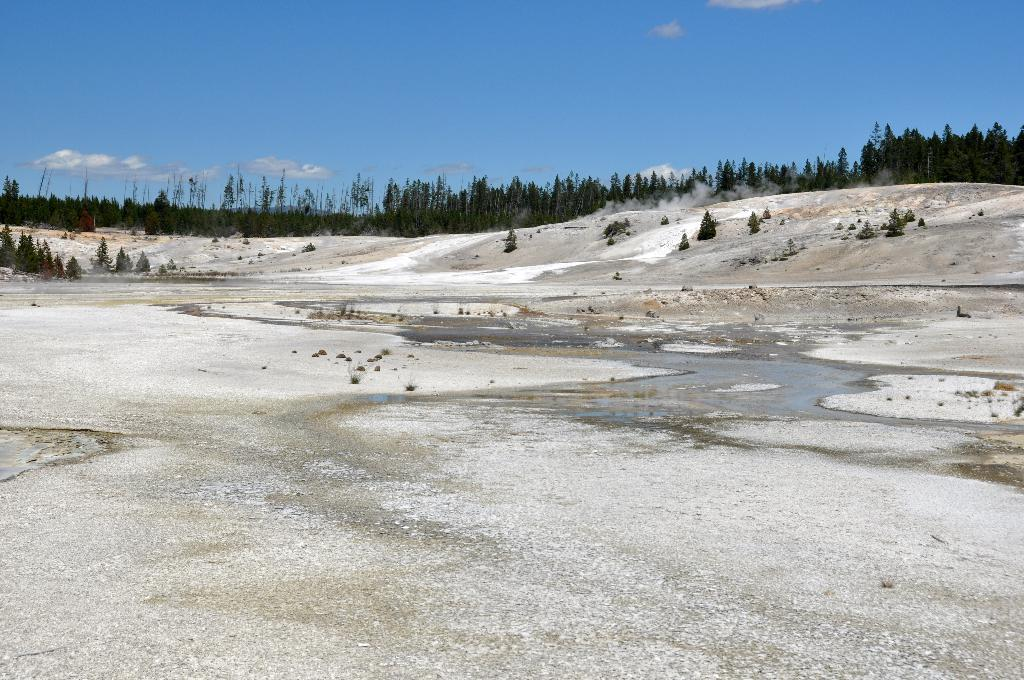What type of vegetation can be seen in the image? There are trees in the image. What natural element is visible alongside the trees? There is water visible in the image. What can be seen in the sky in the image? There are clouds in the sky. What degree of difficulty is required to swing on the tree branch in the image? There is no tree branch or swing present in the image, so it is not possible to determine the degree of difficulty. 